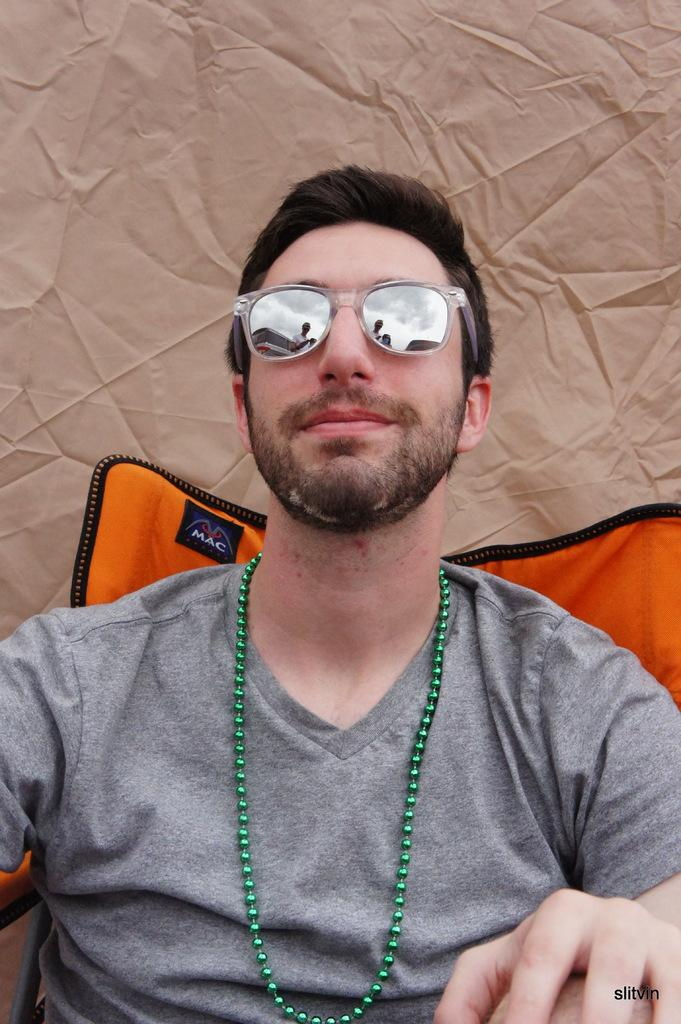What is the main subject in the foreground of the image? There is a person in the foreground of the image. What accessories is the person wearing? The person is wearing a neck piece and goggles. What can be observed about the person's hair? The person has black hair. How many managers are present in the image? There is no mention of a manager in the image, so it cannot be determined if any are present. What type of basket is being used by the person in the image? There is no basket present in the image. 